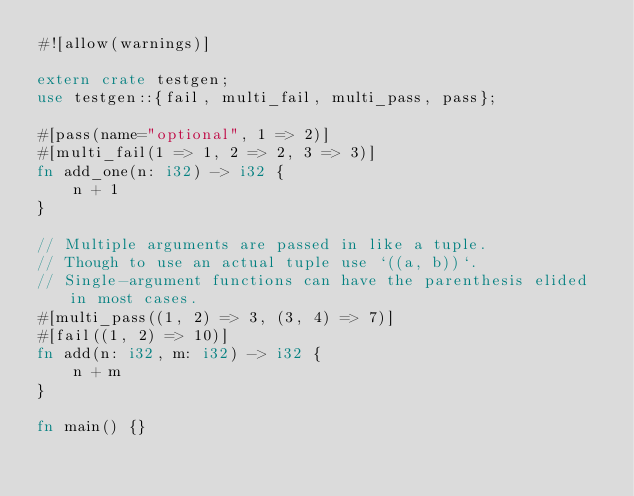<code> <loc_0><loc_0><loc_500><loc_500><_Rust_>#![allow(warnings)]

extern crate testgen;
use testgen::{fail, multi_fail, multi_pass, pass};

#[pass(name="optional", 1 => 2)]
#[multi_fail(1 => 1, 2 => 2, 3 => 3)]
fn add_one(n: i32) -> i32 {
    n + 1
}

// Multiple arguments are passed in like a tuple.
// Though to use an actual tuple use `((a, b))`.
// Single-argument functions can have the parenthesis elided in most cases.
#[multi_pass((1, 2) => 3, (3, 4) => 7)]
#[fail((1, 2) => 10)]
fn add(n: i32, m: i32) -> i32 {
    n + m
}

fn main() {}
</code> 